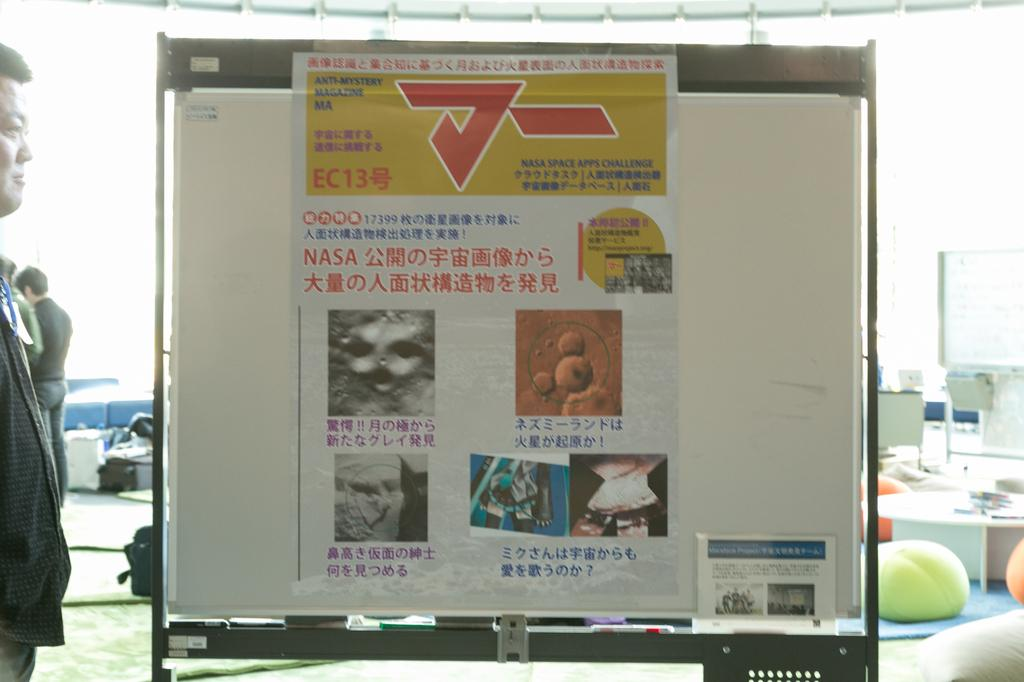Provide a one-sentence caption for the provided image. A sign about the NASA Space APPS Challenge features several photos. 